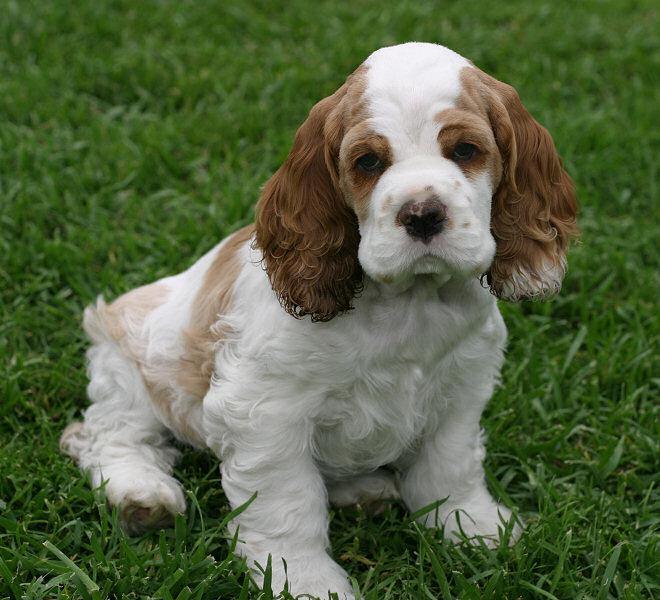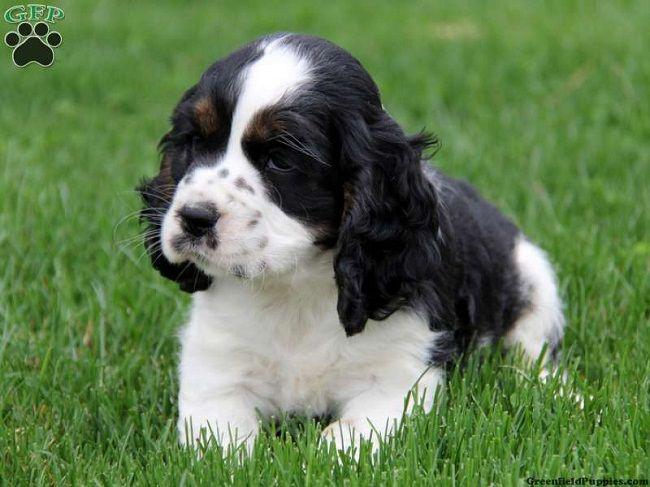The first image is the image on the left, the second image is the image on the right. Examine the images to the left and right. Is the description "Right image shows one dog on green grass, and the dog has white fur on its face with darker fur on its earsand around its eyes." accurate? Answer yes or no. Yes. The first image is the image on the left, the second image is the image on the right. For the images shown, is this caption "The dogs in both images are sitting on the grass." true? Answer yes or no. Yes. 